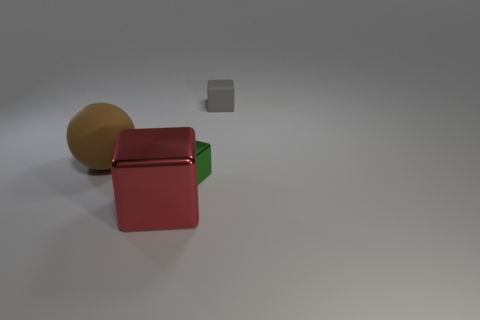Subtract all metal cubes. How many cubes are left? 1 Add 1 gray matte cubes. How many objects exist? 5 Subtract all balls. How many objects are left? 3 Subtract all gray blocks. How many blocks are left? 2 Subtract 1 balls. How many balls are left? 0 Add 1 purple cylinders. How many purple cylinders exist? 1 Subtract 0 blue cubes. How many objects are left? 4 Subtract all purple spheres. Subtract all brown blocks. How many spheres are left? 1 Subtract all brown matte spheres. Subtract all big shiny objects. How many objects are left? 2 Add 3 big red metallic cubes. How many big red metallic cubes are left? 4 